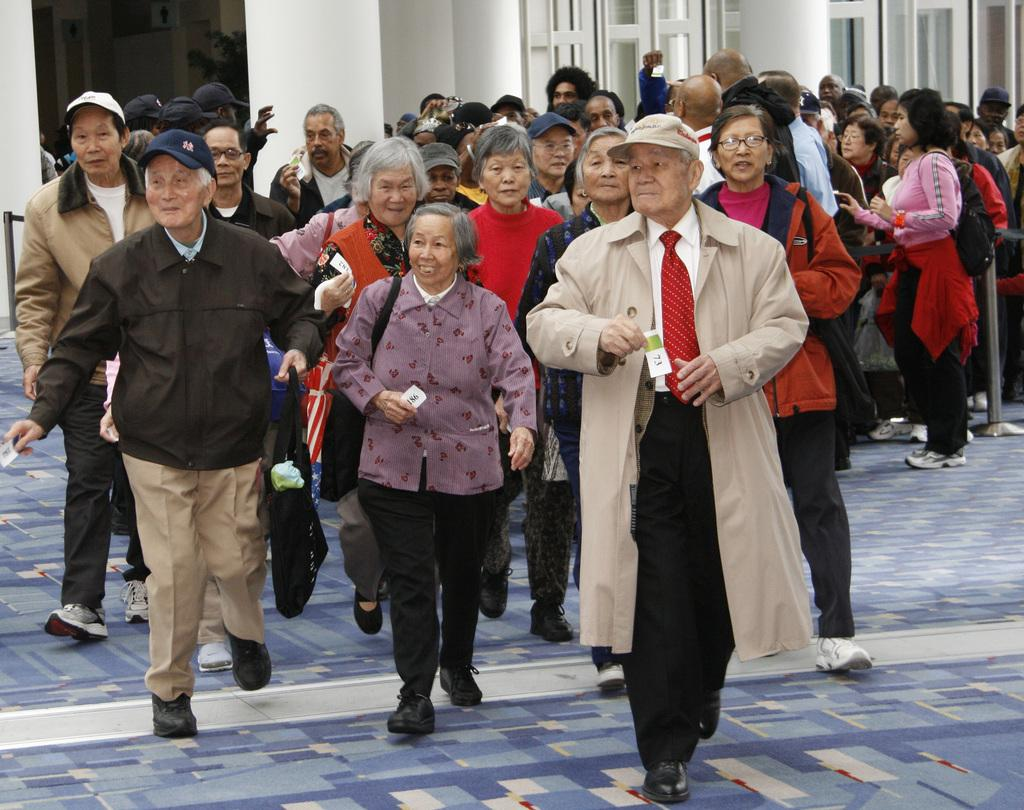What are the people in the image doing? There are many people walking in the image. Can you describe the clothing or accessories of some people in the image? Some people are wearing caps. What are some people carrying in the image? Some people are holding bags. What can be seen in the background of the image? There is a building with windows in the background of the image. What type of oil is being used to light the bulb in the image? There is no bulb or oil present in the image; it features people walking and a building in the background. What policy changes is the governor discussing with the people in the image? There is no governor or discussion present in the image; it only shows people walking and a building in the background. 